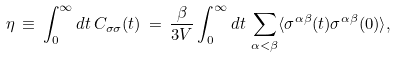Convert formula to latex. <formula><loc_0><loc_0><loc_500><loc_500>\eta \, \equiv \, \int _ { 0 } ^ { \infty } d t \, C _ { \sigma \sigma } ( t ) \, = \, \frac { \beta } { 3 V } \int _ { 0 } ^ { \infty } d t \, \sum _ { \alpha < \beta } \langle \sigma ^ { \alpha \beta } ( t ) \sigma ^ { \alpha \beta } ( 0 ) \rangle ,</formula> 